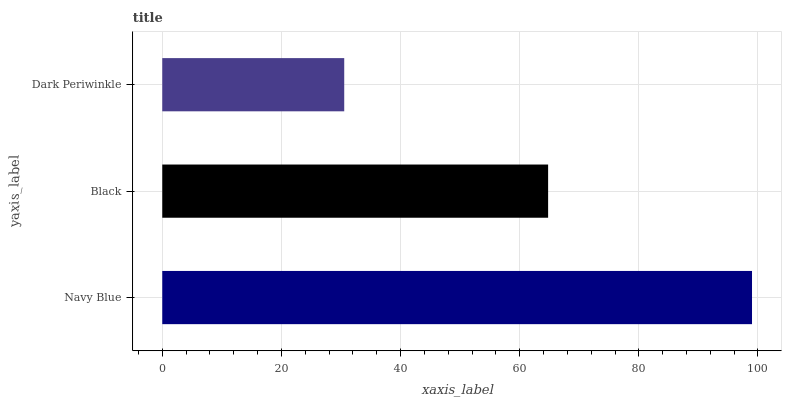Is Dark Periwinkle the minimum?
Answer yes or no. Yes. Is Navy Blue the maximum?
Answer yes or no. Yes. Is Black the minimum?
Answer yes or no. No. Is Black the maximum?
Answer yes or no. No. Is Navy Blue greater than Black?
Answer yes or no. Yes. Is Black less than Navy Blue?
Answer yes or no. Yes. Is Black greater than Navy Blue?
Answer yes or no. No. Is Navy Blue less than Black?
Answer yes or no. No. Is Black the high median?
Answer yes or no. Yes. Is Black the low median?
Answer yes or no. Yes. Is Dark Periwinkle the high median?
Answer yes or no. No. Is Navy Blue the low median?
Answer yes or no. No. 